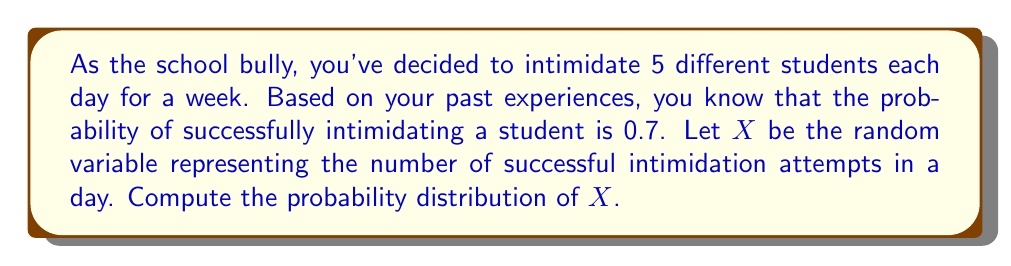Teach me how to tackle this problem. To solve this problem, we need to recognize that this scenario follows a binomial distribution. Here's how we can approach it:

1) Identify the parameters:
   - n (number of trials) = 5 (attempts per day)
   - p (probability of success) = 0.7

2) The probability distribution for a binomial random variable X is given by:

   $$P(X = k) = \binom{n}{k} p^k (1-p)^{n-k}$$

   where k is the number of successes (0 ≤ k ≤ n)

3) Let's calculate the probability for each possible value of X:

   For X = 0: 
   $$P(X = 0) = \binom{5}{0} (0.7)^0 (0.3)^5 = 0.00243$$

   For X = 1:
   $$P(X = 1) = \binom{5}{1} (0.7)^1 (0.3)^4 = 0.02835$$

   For X = 2:
   $$P(X = 2) = \binom{5}{2} (0.7)^2 (0.3)^3 = 0.13230$$

   For X = 3:
   $$P(X = 3) = \binom{5}{3} (0.7)^3 (0.3)^2 = 0.30870$$

   For X = 4:
   $$P(X = 4) = \binom{5}{4} (0.7)^4 (0.3)^1 = 0.36015$$

   For X = 5:
   $$P(X = 5) = \binom{5}{5} (0.7)^5 (0.3)^0 = 0.16807$$

4) The probability distribution is the set of these probabilities for each possible value of X.
Answer: P(X = 0) = 0.00243, P(X = 1) = 0.02835, P(X = 2) = 0.13230, P(X = 3) = 0.30870, P(X = 4) = 0.36015, P(X = 5) = 0.16807 